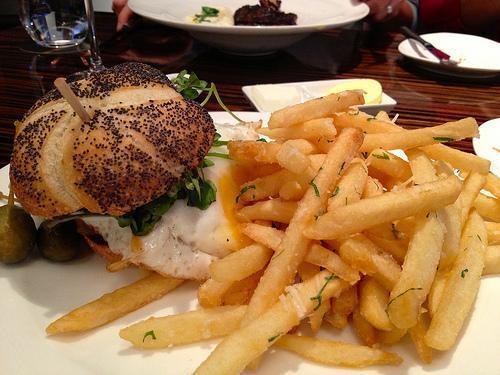How many glasses are visible?
Give a very brief answer. 1. 